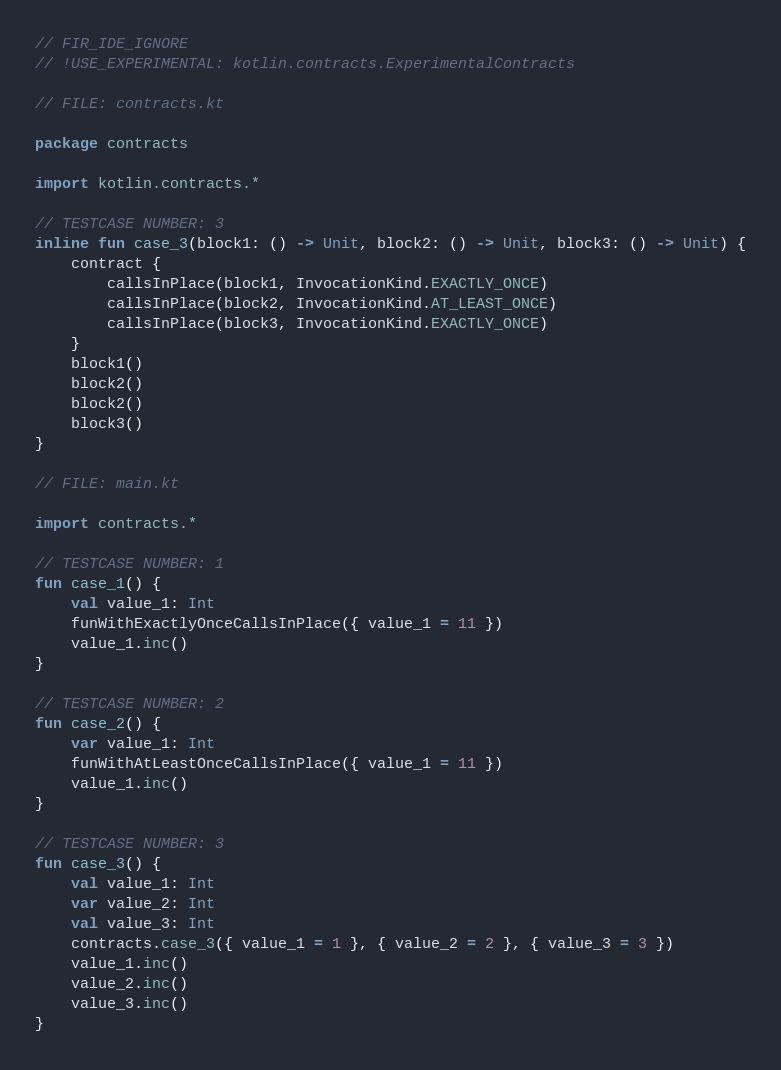<code> <loc_0><loc_0><loc_500><loc_500><_Kotlin_>// FIR_IDE_IGNORE
// !USE_EXPERIMENTAL: kotlin.contracts.ExperimentalContracts

// FILE: contracts.kt

package contracts

import kotlin.contracts.*

// TESTCASE NUMBER: 3
inline fun case_3(block1: () -> Unit, block2: () -> Unit, block3: () -> Unit) {
    contract {
        callsInPlace(block1, InvocationKind.EXACTLY_ONCE)
        callsInPlace(block2, InvocationKind.AT_LEAST_ONCE)
        callsInPlace(block3, InvocationKind.EXACTLY_ONCE)
    }
    block1()
    block2()
    block2()
    block3()
}

// FILE: main.kt

import contracts.*

// TESTCASE NUMBER: 1
fun case_1() {
    val value_1: Int
    funWithExactlyOnceCallsInPlace({ value_1 = 11 })
    value_1.inc()
}

// TESTCASE NUMBER: 2
fun case_2() {
    var value_1: Int
    funWithAtLeastOnceCallsInPlace({ value_1 = 11 })
    value_1.inc()
}

// TESTCASE NUMBER: 3
fun case_3() {
    val value_1: Int
    var value_2: Int
    val value_3: Int
    contracts.case_3({ value_1 = 1 }, { value_2 = 2 }, { value_3 = 3 })
    value_1.inc()
    value_2.inc()
    value_3.inc()
}
</code> 